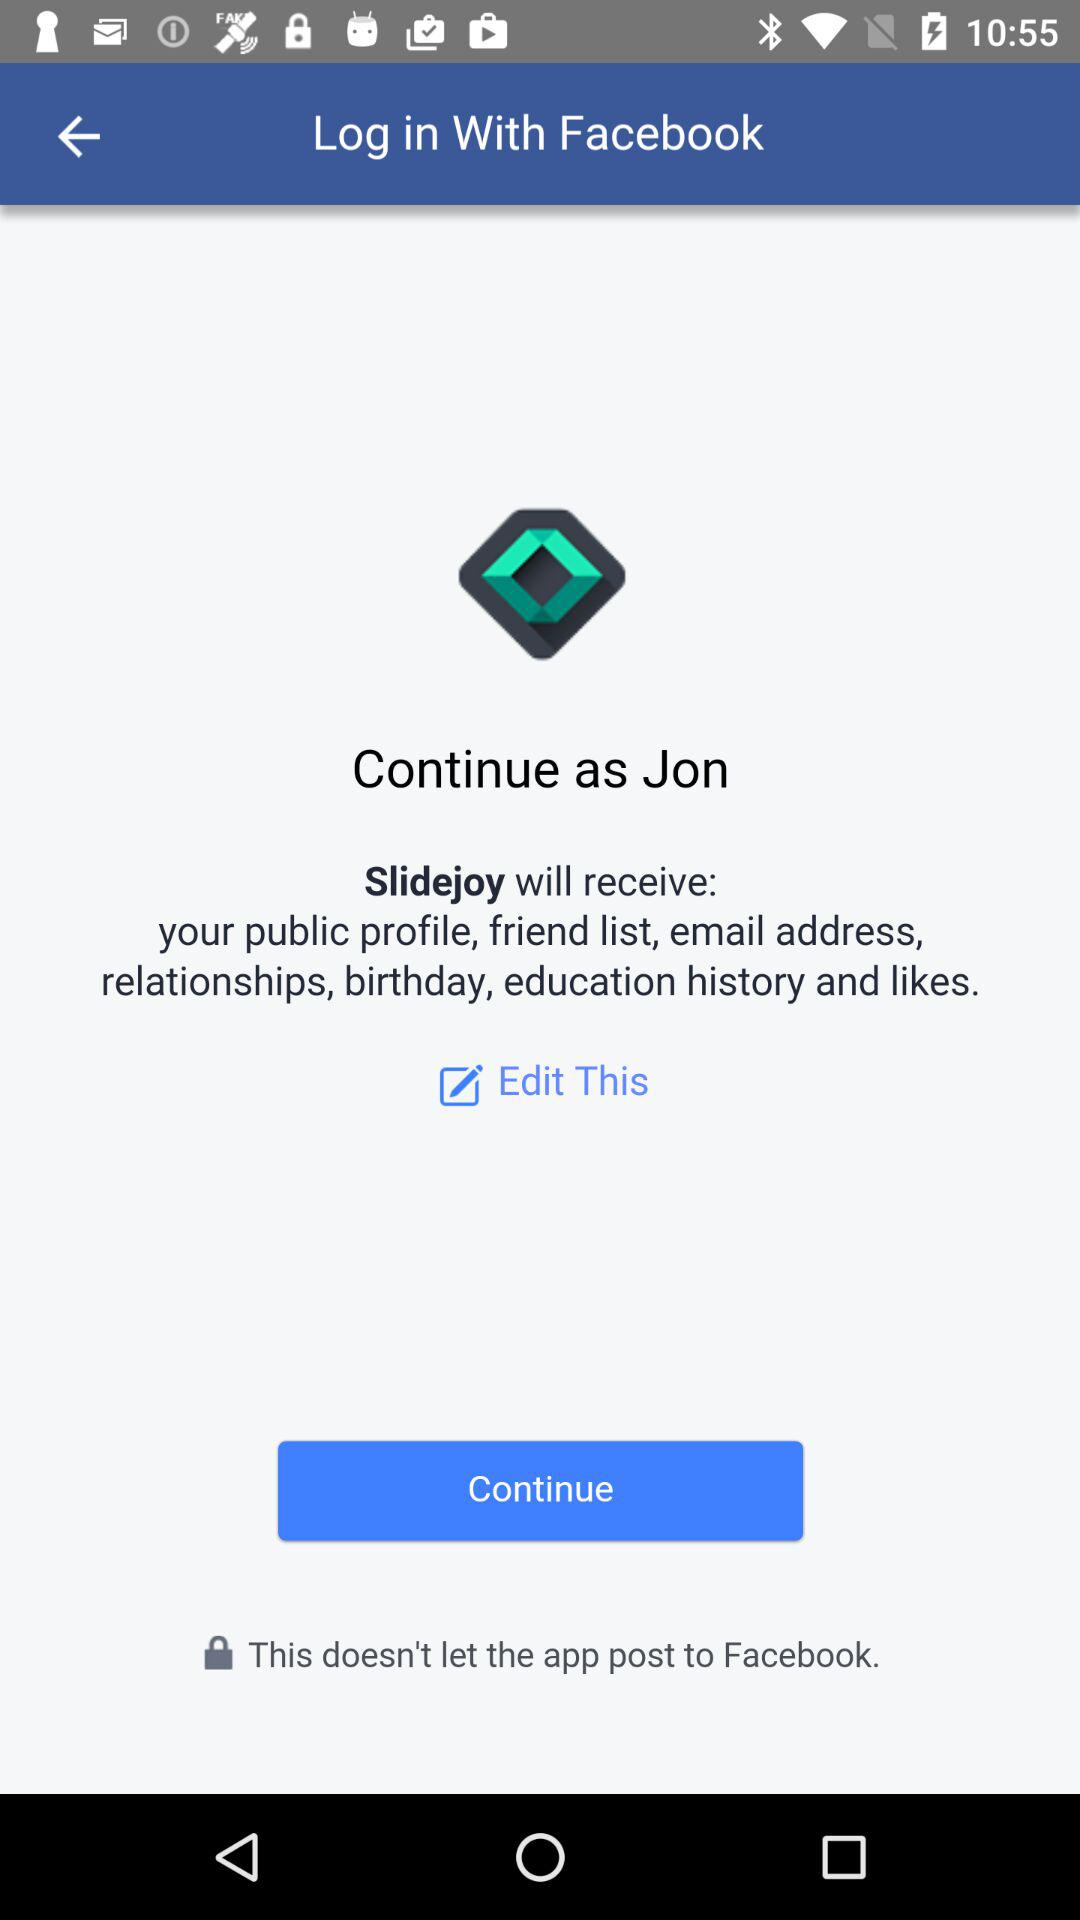What is the user name to continue on the login page? The user name to continue on the login page is Jon. 